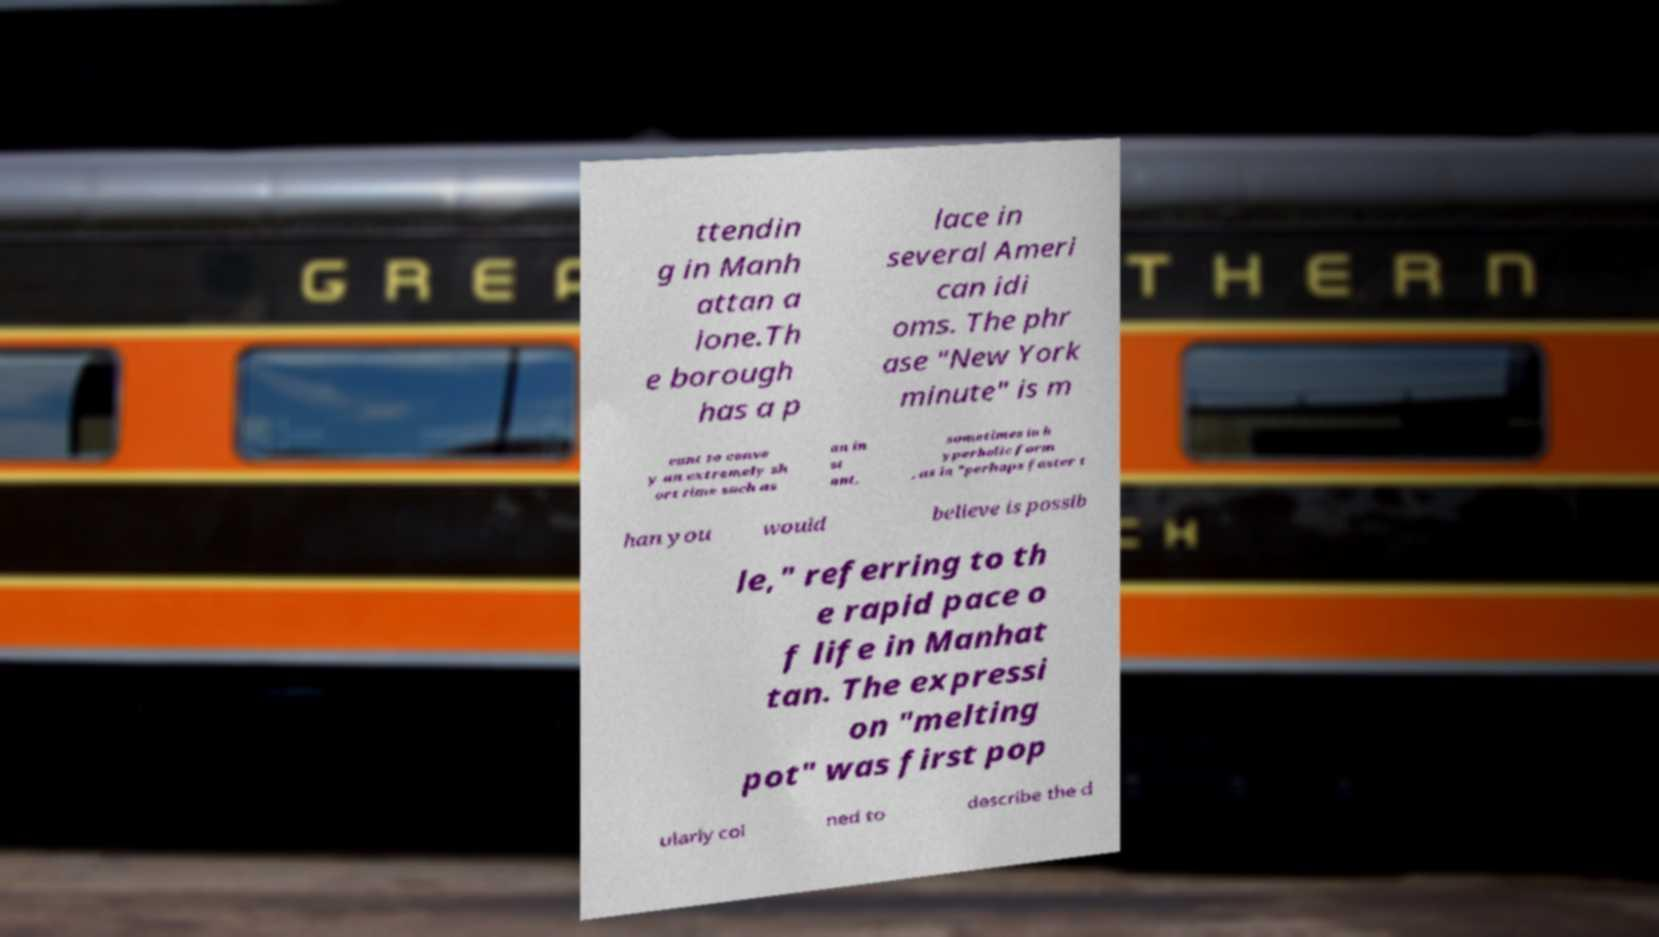Could you extract and type out the text from this image? ttendin g in Manh attan a lone.Th e borough has a p lace in several Ameri can idi oms. The phr ase "New York minute" is m eant to conve y an extremely sh ort time such as an in st ant, sometimes in h yperbolic form , as in "perhaps faster t han you would believe is possib le," referring to th e rapid pace o f life in Manhat tan. The expressi on "melting pot" was first pop ularly coi ned to describe the d 